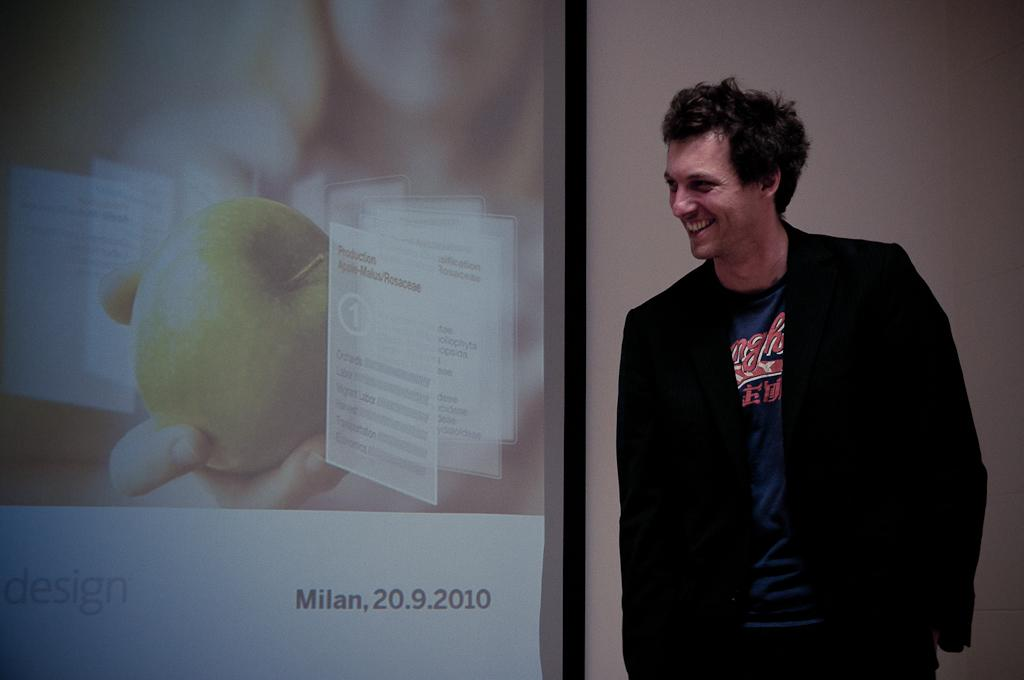<image>
Give a short and clear explanation of the subsequent image. A man stands in front of a projector screen that says Milan, 20.9.2010 on it. 